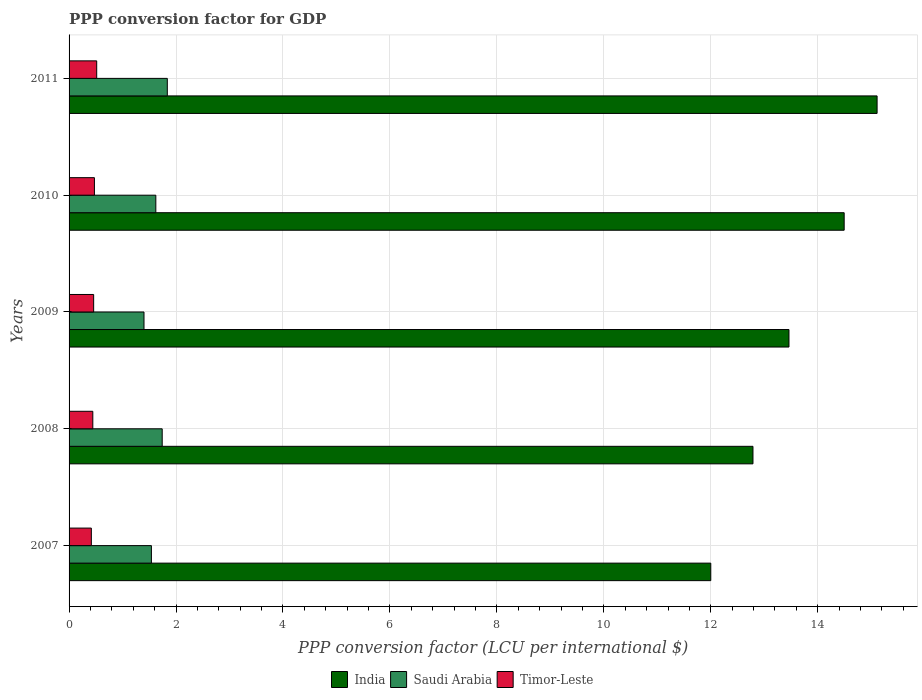How many different coloured bars are there?
Give a very brief answer. 3. How many bars are there on the 2nd tick from the top?
Keep it short and to the point. 3. What is the PPP conversion factor for GDP in India in 2008?
Keep it short and to the point. 12.79. Across all years, what is the maximum PPP conversion factor for GDP in Saudi Arabia?
Your answer should be very brief. 1.84. Across all years, what is the minimum PPP conversion factor for GDP in Saudi Arabia?
Your answer should be compact. 1.4. What is the total PPP conversion factor for GDP in India in the graph?
Ensure brevity in your answer.  67.85. What is the difference between the PPP conversion factor for GDP in Saudi Arabia in 2009 and that in 2010?
Keep it short and to the point. -0.22. What is the difference between the PPP conversion factor for GDP in Timor-Leste in 2010 and the PPP conversion factor for GDP in Saudi Arabia in 2008?
Your response must be concise. -1.27. What is the average PPP conversion factor for GDP in Saudi Arabia per year?
Offer a very short reply. 1.63. In the year 2011, what is the difference between the PPP conversion factor for GDP in India and PPP conversion factor for GDP in Timor-Leste?
Your response must be concise. 14.59. In how many years, is the PPP conversion factor for GDP in Saudi Arabia greater than 2 LCU?
Offer a terse response. 0. What is the ratio of the PPP conversion factor for GDP in Saudi Arabia in 2009 to that in 2010?
Your answer should be compact. 0.86. Is the difference between the PPP conversion factor for GDP in India in 2007 and 2011 greater than the difference between the PPP conversion factor for GDP in Timor-Leste in 2007 and 2011?
Offer a terse response. No. What is the difference between the highest and the second highest PPP conversion factor for GDP in Timor-Leste?
Give a very brief answer. 0.04. What is the difference between the highest and the lowest PPP conversion factor for GDP in Timor-Leste?
Offer a terse response. 0.1. What does the 1st bar from the top in 2008 represents?
Your answer should be compact. Timor-Leste. What does the 2nd bar from the bottom in 2007 represents?
Keep it short and to the point. Saudi Arabia. How many bars are there?
Your answer should be very brief. 15. What is the difference between two consecutive major ticks on the X-axis?
Make the answer very short. 2. Are the values on the major ticks of X-axis written in scientific E-notation?
Offer a very short reply. No. Does the graph contain grids?
Ensure brevity in your answer.  Yes. Where does the legend appear in the graph?
Your answer should be very brief. Bottom center. What is the title of the graph?
Provide a short and direct response. PPP conversion factor for GDP. Does "Somalia" appear as one of the legend labels in the graph?
Provide a succinct answer. No. What is the label or title of the X-axis?
Your response must be concise. PPP conversion factor (LCU per international $). What is the label or title of the Y-axis?
Your response must be concise. Years. What is the PPP conversion factor (LCU per international $) of India in 2007?
Offer a very short reply. 12. What is the PPP conversion factor (LCU per international $) of Saudi Arabia in 2007?
Give a very brief answer. 1.54. What is the PPP conversion factor (LCU per international $) in Timor-Leste in 2007?
Make the answer very short. 0.42. What is the PPP conversion factor (LCU per international $) of India in 2008?
Ensure brevity in your answer.  12.79. What is the PPP conversion factor (LCU per international $) in Saudi Arabia in 2008?
Your response must be concise. 1.74. What is the PPP conversion factor (LCU per international $) of Timor-Leste in 2008?
Your answer should be compact. 0.44. What is the PPP conversion factor (LCU per international $) in India in 2009?
Offer a very short reply. 13.46. What is the PPP conversion factor (LCU per international $) in Saudi Arabia in 2009?
Your response must be concise. 1.4. What is the PPP conversion factor (LCU per international $) of Timor-Leste in 2009?
Provide a succinct answer. 0.46. What is the PPP conversion factor (LCU per international $) in India in 2010?
Offer a very short reply. 14.49. What is the PPP conversion factor (LCU per international $) in Saudi Arabia in 2010?
Your answer should be compact. 1.62. What is the PPP conversion factor (LCU per international $) in Timor-Leste in 2010?
Your response must be concise. 0.47. What is the PPP conversion factor (LCU per international $) in India in 2011?
Provide a succinct answer. 15.11. What is the PPP conversion factor (LCU per international $) of Saudi Arabia in 2011?
Offer a very short reply. 1.84. What is the PPP conversion factor (LCU per international $) in Timor-Leste in 2011?
Your response must be concise. 0.52. Across all years, what is the maximum PPP conversion factor (LCU per international $) of India?
Offer a very short reply. 15.11. Across all years, what is the maximum PPP conversion factor (LCU per international $) in Saudi Arabia?
Offer a very short reply. 1.84. Across all years, what is the maximum PPP conversion factor (LCU per international $) in Timor-Leste?
Your answer should be compact. 0.52. Across all years, what is the minimum PPP conversion factor (LCU per international $) of India?
Offer a very short reply. 12. Across all years, what is the minimum PPP conversion factor (LCU per international $) in Saudi Arabia?
Offer a terse response. 1.4. Across all years, what is the minimum PPP conversion factor (LCU per international $) in Timor-Leste?
Ensure brevity in your answer.  0.42. What is the total PPP conversion factor (LCU per international $) of India in the graph?
Keep it short and to the point. 67.85. What is the total PPP conversion factor (LCU per international $) in Saudi Arabia in the graph?
Your response must be concise. 8.14. What is the total PPP conversion factor (LCU per international $) of Timor-Leste in the graph?
Your answer should be very brief. 2.31. What is the difference between the PPP conversion factor (LCU per international $) in India in 2007 and that in 2008?
Provide a succinct answer. -0.79. What is the difference between the PPP conversion factor (LCU per international $) of Saudi Arabia in 2007 and that in 2008?
Your response must be concise. -0.2. What is the difference between the PPP conversion factor (LCU per international $) of Timor-Leste in 2007 and that in 2008?
Offer a very short reply. -0.03. What is the difference between the PPP conversion factor (LCU per international $) in India in 2007 and that in 2009?
Give a very brief answer. -1.46. What is the difference between the PPP conversion factor (LCU per international $) in Saudi Arabia in 2007 and that in 2009?
Give a very brief answer. 0.14. What is the difference between the PPP conversion factor (LCU per international $) of Timor-Leste in 2007 and that in 2009?
Your answer should be very brief. -0.04. What is the difference between the PPP conversion factor (LCU per international $) in India in 2007 and that in 2010?
Offer a terse response. -2.49. What is the difference between the PPP conversion factor (LCU per international $) in Saudi Arabia in 2007 and that in 2010?
Keep it short and to the point. -0.08. What is the difference between the PPP conversion factor (LCU per international $) of Timor-Leste in 2007 and that in 2010?
Your answer should be very brief. -0.06. What is the difference between the PPP conversion factor (LCU per international $) of India in 2007 and that in 2011?
Keep it short and to the point. -3.11. What is the difference between the PPP conversion factor (LCU per international $) of Saudi Arabia in 2007 and that in 2011?
Keep it short and to the point. -0.3. What is the difference between the PPP conversion factor (LCU per international $) of Timor-Leste in 2007 and that in 2011?
Give a very brief answer. -0.1. What is the difference between the PPP conversion factor (LCU per international $) in India in 2008 and that in 2009?
Ensure brevity in your answer.  -0.67. What is the difference between the PPP conversion factor (LCU per international $) in Saudi Arabia in 2008 and that in 2009?
Offer a very short reply. 0.34. What is the difference between the PPP conversion factor (LCU per international $) of Timor-Leste in 2008 and that in 2009?
Your response must be concise. -0.02. What is the difference between the PPP conversion factor (LCU per international $) of India in 2008 and that in 2010?
Your response must be concise. -1.71. What is the difference between the PPP conversion factor (LCU per international $) in Saudi Arabia in 2008 and that in 2010?
Keep it short and to the point. 0.12. What is the difference between the PPP conversion factor (LCU per international $) in Timor-Leste in 2008 and that in 2010?
Your response must be concise. -0.03. What is the difference between the PPP conversion factor (LCU per international $) in India in 2008 and that in 2011?
Offer a very short reply. -2.32. What is the difference between the PPP conversion factor (LCU per international $) of Saudi Arabia in 2008 and that in 2011?
Your answer should be very brief. -0.1. What is the difference between the PPP conversion factor (LCU per international $) in Timor-Leste in 2008 and that in 2011?
Give a very brief answer. -0.07. What is the difference between the PPP conversion factor (LCU per international $) in India in 2009 and that in 2010?
Your answer should be very brief. -1.03. What is the difference between the PPP conversion factor (LCU per international $) of Saudi Arabia in 2009 and that in 2010?
Provide a short and direct response. -0.22. What is the difference between the PPP conversion factor (LCU per international $) of Timor-Leste in 2009 and that in 2010?
Your answer should be compact. -0.01. What is the difference between the PPP conversion factor (LCU per international $) in India in 2009 and that in 2011?
Provide a succinct answer. -1.65. What is the difference between the PPP conversion factor (LCU per international $) of Saudi Arabia in 2009 and that in 2011?
Your response must be concise. -0.44. What is the difference between the PPP conversion factor (LCU per international $) of Timor-Leste in 2009 and that in 2011?
Give a very brief answer. -0.06. What is the difference between the PPP conversion factor (LCU per international $) of India in 2010 and that in 2011?
Provide a succinct answer. -0.62. What is the difference between the PPP conversion factor (LCU per international $) in Saudi Arabia in 2010 and that in 2011?
Offer a terse response. -0.21. What is the difference between the PPP conversion factor (LCU per international $) in Timor-Leste in 2010 and that in 2011?
Your response must be concise. -0.04. What is the difference between the PPP conversion factor (LCU per international $) of India in 2007 and the PPP conversion factor (LCU per international $) of Saudi Arabia in 2008?
Keep it short and to the point. 10.26. What is the difference between the PPP conversion factor (LCU per international $) in India in 2007 and the PPP conversion factor (LCU per international $) in Timor-Leste in 2008?
Make the answer very short. 11.56. What is the difference between the PPP conversion factor (LCU per international $) of Saudi Arabia in 2007 and the PPP conversion factor (LCU per international $) of Timor-Leste in 2008?
Your response must be concise. 1.1. What is the difference between the PPP conversion factor (LCU per international $) in India in 2007 and the PPP conversion factor (LCU per international $) in Saudi Arabia in 2009?
Provide a short and direct response. 10.6. What is the difference between the PPP conversion factor (LCU per international $) of India in 2007 and the PPP conversion factor (LCU per international $) of Timor-Leste in 2009?
Give a very brief answer. 11.54. What is the difference between the PPP conversion factor (LCU per international $) of Saudi Arabia in 2007 and the PPP conversion factor (LCU per international $) of Timor-Leste in 2009?
Ensure brevity in your answer.  1.08. What is the difference between the PPP conversion factor (LCU per international $) of India in 2007 and the PPP conversion factor (LCU per international $) of Saudi Arabia in 2010?
Provide a succinct answer. 10.38. What is the difference between the PPP conversion factor (LCU per international $) of India in 2007 and the PPP conversion factor (LCU per international $) of Timor-Leste in 2010?
Your answer should be very brief. 11.53. What is the difference between the PPP conversion factor (LCU per international $) of Saudi Arabia in 2007 and the PPP conversion factor (LCU per international $) of Timor-Leste in 2010?
Provide a short and direct response. 1.07. What is the difference between the PPP conversion factor (LCU per international $) in India in 2007 and the PPP conversion factor (LCU per international $) in Saudi Arabia in 2011?
Offer a very short reply. 10.16. What is the difference between the PPP conversion factor (LCU per international $) of India in 2007 and the PPP conversion factor (LCU per international $) of Timor-Leste in 2011?
Your response must be concise. 11.48. What is the difference between the PPP conversion factor (LCU per international $) in Saudi Arabia in 2007 and the PPP conversion factor (LCU per international $) in Timor-Leste in 2011?
Ensure brevity in your answer.  1.02. What is the difference between the PPP conversion factor (LCU per international $) in India in 2008 and the PPP conversion factor (LCU per international $) in Saudi Arabia in 2009?
Provide a succinct answer. 11.39. What is the difference between the PPP conversion factor (LCU per international $) in India in 2008 and the PPP conversion factor (LCU per international $) in Timor-Leste in 2009?
Ensure brevity in your answer.  12.33. What is the difference between the PPP conversion factor (LCU per international $) of Saudi Arabia in 2008 and the PPP conversion factor (LCU per international $) of Timor-Leste in 2009?
Give a very brief answer. 1.28. What is the difference between the PPP conversion factor (LCU per international $) in India in 2008 and the PPP conversion factor (LCU per international $) in Saudi Arabia in 2010?
Keep it short and to the point. 11.17. What is the difference between the PPP conversion factor (LCU per international $) in India in 2008 and the PPP conversion factor (LCU per international $) in Timor-Leste in 2010?
Give a very brief answer. 12.31. What is the difference between the PPP conversion factor (LCU per international $) in Saudi Arabia in 2008 and the PPP conversion factor (LCU per international $) in Timor-Leste in 2010?
Provide a short and direct response. 1.27. What is the difference between the PPP conversion factor (LCU per international $) of India in 2008 and the PPP conversion factor (LCU per international $) of Saudi Arabia in 2011?
Your response must be concise. 10.95. What is the difference between the PPP conversion factor (LCU per international $) in India in 2008 and the PPP conversion factor (LCU per international $) in Timor-Leste in 2011?
Provide a succinct answer. 12.27. What is the difference between the PPP conversion factor (LCU per international $) in Saudi Arabia in 2008 and the PPP conversion factor (LCU per international $) in Timor-Leste in 2011?
Provide a succinct answer. 1.22. What is the difference between the PPP conversion factor (LCU per international $) in India in 2009 and the PPP conversion factor (LCU per international $) in Saudi Arabia in 2010?
Give a very brief answer. 11.84. What is the difference between the PPP conversion factor (LCU per international $) in India in 2009 and the PPP conversion factor (LCU per international $) in Timor-Leste in 2010?
Offer a very short reply. 12.99. What is the difference between the PPP conversion factor (LCU per international $) in Saudi Arabia in 2009 and the PPP conversion factor (LCU per international $) in Timor-Leste in 2010?
Offer a very short reply. 0.93. What is the difference between the PPP conversion factor (LCU per international $) of India in 2009 and the PPP conversion factor (LCU per international $) of Saudi Arabia in 2011?
Make the answer very short. 11.62. What is the difference between the PPP conversion factor (LCU per international $) in India in 2009 and the PPP conversion factor (LCU per international $) in Timor-Leste in 2011?
Make the answer very short. 12.94. What is the difference between the PPP conversion factor (LCU per international $) of Saudi Arabia in 2009 and the PPP conversion factor (LCU per international $) of Timor-Leste in 2011?
Make the answer very short. 0.88. What is the difference between the PPP conversion factor (LCU per international $) of India in 2010 and the PPP conversion factor (LCU per international $) of Saudi Arabia in 2011?
Your response must be concise. 12.66. What is the difference between the PPP conversion factor (LCU per international $) of India in 2010 and the PPP conversion factor (LCU per international $) of Timor-Leste in 2011?
Give a very brief answer. 13.98. What is the difference between the PPP conversion factor (LCU per international $) in Saudi Arabia in 2010 and the PPP conversion factor (LCU per international $) in Timor-Leste in 2011?
Keep it short and to the point. 1.11. What is the average PPP conversion factor (LCU per international $) in India per year?
Offer a very short reply. 13.57. What is the average PPP conversion factor (LCU per international $) in Saudi Arabia per year?
Provide a short and direct response. 1.63. What is the average PPP conversion factor (LCU per international $) of Timor-Leste per year?
Offer a very short reply. 0.46. In the year 2007, what is the difference between the PPP conversion factor (LCU per international $) in India and PPP conversion factor (LCU per international $) in Saudi Arabia?
Keep it short and to the point. 10.46. In the year 2007, what is the difference between the PPP conversion factor (LCU per international $) of India and PPP conversion factor (LCU per international $) of Timor-Leste?
Your answer should be very brief. 11.58. In the year 2007, what is the difference between the PPP conversion factor (LCU per international $) in Saudi Arabia and PPP conversion factor (LCU per international $) in Timor-Leste?
Provide a short and direct response. 1.12. In the year 2008, what is the difference between the PPP conversion factor (LCU per international $) in India and PPP conversion factor (LCU per international $) in Saudi Arabia?
Give a very brief answer. 11.05. In the year 2008, what is the difference between the PPP conversion factor (LCU per international $) in India and PPP conversion factor (LCU per international $) in Timor-Leste?
Your answer should be compact. 12.34. In the year 2008, what is the difference between the PPP conversion factor (LCU per international $) of Saudi Arabia and PPP conversion factor (LCU per international $) of Timor-Leste?
Offer a terse response. 1.3. In the year 2009, what is the difference between the PPP conversion factor (LCU per international $) in India and PPP conversion factor (LCU per international $) in Saudi Arabia?
Make the answer very short. 12.06. In the year 2009, what is the difference between the PPP conversion factor (LCU per international $) of India and PPP conversion factor (LCU per international $) of Timor-Leste?
Your response must be concise. 13. In the year 2009, what is the difference between the PPP conversion factor (LCU per international $) of Saudi Arabia and PPP conversion factor (LCU per international $) of Timor-Leste?
Provide a short and direct response. 0.94. In the year 2010, what is the difference between the PPP conversion factor (LCU per international $) of India and PPP conversion factor (LCU per international $) of Saudi Arabia?
Make the answer very short. 12.87. In the year 2010, what is the difference between the PPP conversion factor (LCU per international $) in India and PPP conversion factor (LCU per international $) in Timor-Leste?
Offer a very short reply. 14.02. In the year 2010, what is the difference between the PPP conversion factor (LCU per international $) of Saudi Arabia and PPP conversion factor (LCU per international $) of Timor-Leste?
Make the answer very short. 1.15. In the year 2011, what is the difference between the PPP conversion factor (LCU per international $) in India and PPP conversion factor (LCU per international $) in Saudi Arabia?
Give a very brief answer. 13.27. In the year 2011, what is the difference between the PPP conversion factor (LCU per international $) of India and PPP conversion factor (LCU per international $) of Timor-Leste?
Keep it short and to the point. 14.59. In the year 2011, what is the difference between the PPP conversion factor (LCU per international $) in Saudi Arabia and PPP conversion factor (LCU per international $) in Timor-Leste?
Provide a succinct answer. 1.32. What is the ratio of the PPP conversion factor (LCU per international $) in India in 2007 to that in 2008?
Give a very brief answer. 0.94. What is the ratio of the PPP conversion factor (LCU per international $) of Saudi Arabia in 2007 to that in 2008?
Provide a succinct answer. 0.88. What is the ratio of the PPP conversion factor (LCU per international $) of Timor-Leste in 2007 to that in 2008?
Provide a succinct answer. 0.94. What is the ratio of the PPP conversion factor (LCU per international $) in India in 2007 to that in 2009?
Offer a very short reply. 0.89. What is the ratio of the PPP conversion factor (LCU per international $) of Saudi Arabia in 2007 to that in 2009?
Provide a succinct answer. 1.1. What is the ratio of the PPP conversion factor (LCU per international $) in Timor-Leste in 2007 to that in 2009?
Provide a succinct answer. 0.91. What is the ratio of the PPP conversion factor (LCU per international $) in India in 2007 to that in 2010?
Your answer should be very brief. 0.83. What is the ratio of the PPP conversion factor (LCU per international $) of Saudi Arabia in 2007 to that in 2010?
Your answer should be compact. 0.95. What is the ratio of the PPP conversion factor (LCU per international $) of Timor-Leste in 2007 to that in 2010?
Ensure brevity in your answer.  0.88. What is the ratio of the PPP conversion factor (LCU per international $) of India in 2007 to that in 2011?
Your answer should be very brief. 0.79. What is the ratio of the PPP conversion factor (LCU per international $) in Saudi Arabia in 2007 to that in 2011?
Provide a succinct answer. 0.84. What is the ratio of the PPP conversion factor (LCU per international $) in Timor-Leste in 2007 to that in 2011?
Provide a short and direct response. 0.81. What is the ratio of the PPP conversion factor (LCU per international $) in India in 2008 to that in 2009?
Ensure brevity in your answer.  0.95. What is the ratio of the PPP conversion factor (LCU per international $) in Saudi Arabia in 2008 to that in 2009?
Provide a short and direct response. 1.24. What is the ratio of the PPP conversion factor (LCU per international $) of Timor-Leste in 2008 to that in 2009?
Provide a succinct answer. 0.97. What is the ratio of the PPP conversion factor (LCU per international $) in India in 2008 to that in 2010?
Give a very brief answer. 0.88. What is the ratio of the PPP conversion factor (LCU per international $) of Saudi Arabia in 2008 to that in 2010?
Offer a terse response. 1.07. What is the ratio of the PPP conversion factor (LCU per international $) in Timor-Leste in 2008 to that in 2010?
Your answer should be very brief. 0.94. What is the ratio of the PPP conversion factor (LCU per international $) in India in 2008 to that in 2011?
Keep it short and to the point. 0.85. What is the ratio of the PPP conversion factor (LCU per international $) of Saudi Arabia in 2008 to that in 2011?
Your response must be concise. 0.95. What is the ratio of the PPP conversion factor (LCU per international $) in Timor-Leste in 2008 to that in 2011?
Provide a short and direct response. 0.86. What is the ratio of the PPP conversion factor (LCU per international $) of India in 2009 to that in 2010?
Provide a short and direct response. 0.93. What is the ratio of the PPP conversion factor (LCU per international $) of Saudi Arabia in 2009 to that in 2010?
Offer a terse response. 0.86. What is the ratio of the PPP conversion factor (LCU per international $) of Timor-Leste in 2009 to that in 2010?
Your response must be concise. 0.97. What is the ratio of the PPP conversion factor (LCU per international $) in India in 2009 to that in 2011?
Offer a very short reply. 0.89. What is the ratio of the PPP conversion factor (LCU per international $) of Saudi Arabia in 2009 to that in 2011?
Your answer should be compact. 0.76. What is the ratio of the PPP conversion factor (LCU per international $) in Timor-Leste in 2009 to that in 2011?
Offer a very short reply. 0.89. What is the ratio of the PPP conversion factor (LCU per international $) in India in 2010 to that in 2011?
Offer a very short reply. 0.96. What is the ratio of the PPP conversion factor (LCU per international $) of Saudi Arabia in 2010 to that in 2011?
Give a very brief answer. 0.88. What is the ratio of the PPP conversion factor (LCU per international $) in Timor-Leste in 2010 to that in 2011?
Offer a very short reply. 0.92. What is the difference between the highest and the second highest PPP conversion factor (LCU per international $) of India?
Offer a very short reply. 0.62. What is the difference between the highest and the second highest PPP conversion factor (LCU per international $) of Saudi Arabia?
Make the answer very short. 0.1. What is the difference between the highest and the second highest PPP conversion factor (LCU per international $) of Timor-Leste?
Ensure brevity in your answer.  0.04. What is the difference between the highest and the lowest PPP conversion factor (LCU per international $) in India?
Give a very brief answer. 3.11. What is the difference between the highest and the lowest PPP conversion factor (LCU per international $) in Saudi Arabia?
Make the answer very short. 0.44. What is the difference between the highest and the lowest PPP conversion factor (LCU per international $) in Timor-Leste?
Your answer should be compact. 0.1. 